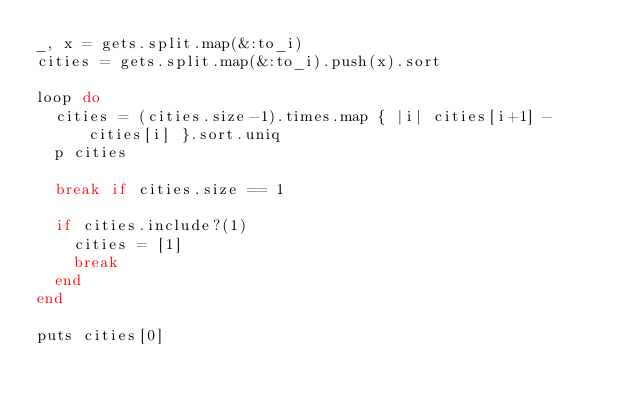Convert code to text. <code><loc_0><loc_0><loc_500><loc_500><_Ruby_>_, x = gets.split.map(&:to_i)
cities = gets.split.map(&:to_i).push(x).sort

loop do
  cities = (cities.size-1).times.map { |i| cities[i+1] - cities[i] }.sort.uniq
  p cities

  break if cities.size == 1

  if cities.include?(1)
    cities = [1]
    break
  end
end

puts cities[0]</code> 